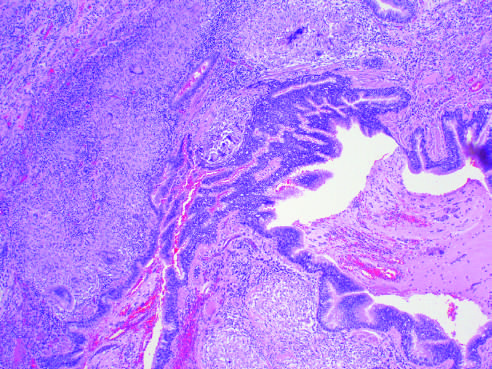what are present?
Answer the question using a single word or phrase. Characteristic peribronchial noncaseating granulomas with many giant cells 